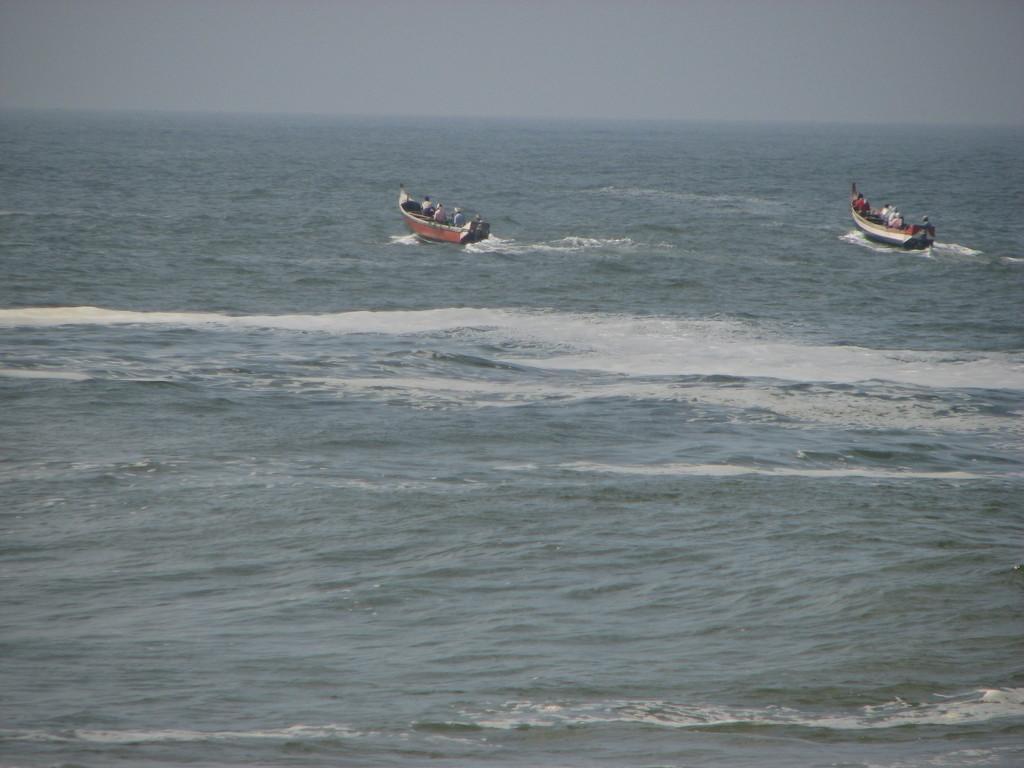What type of vehicles are in the image? There are two brown boats in the image. What are the boats doing in the image? The boats are moving in the seawater. What is visible at the top of the image? The sky is visible at the top of the image. What type of leaf can be seen falling from the sky in the image? There is no leaf present in the image, and no leaves are falling from the sky. 